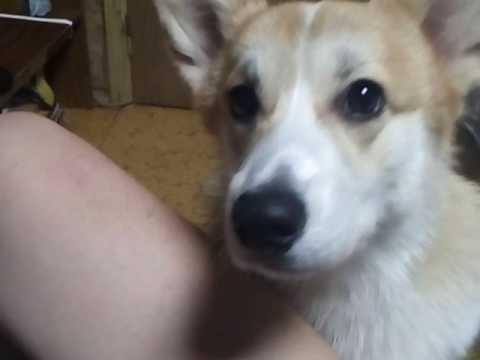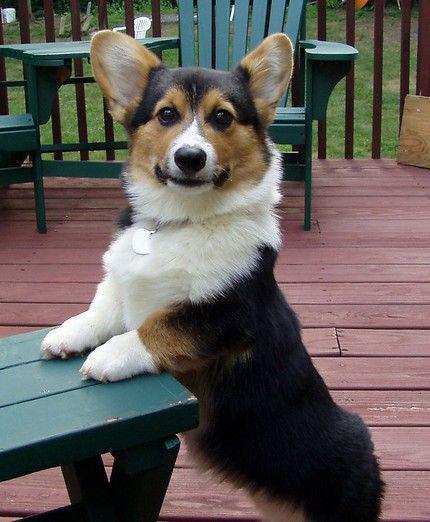The first image is the image on the left, the second image is the image on the right. Assess this claim about the two images: "An image shows a corgi dog without a leash, standing on all fours and looking upward at the camera.". Correct or not? Answer yes or no. No. The first image is the image on the left, the second image is the image on the right. Considering the images on both sides, is "At least one dog's tongue is hanging out of its mouth." valid? Answer yes or no. No. 